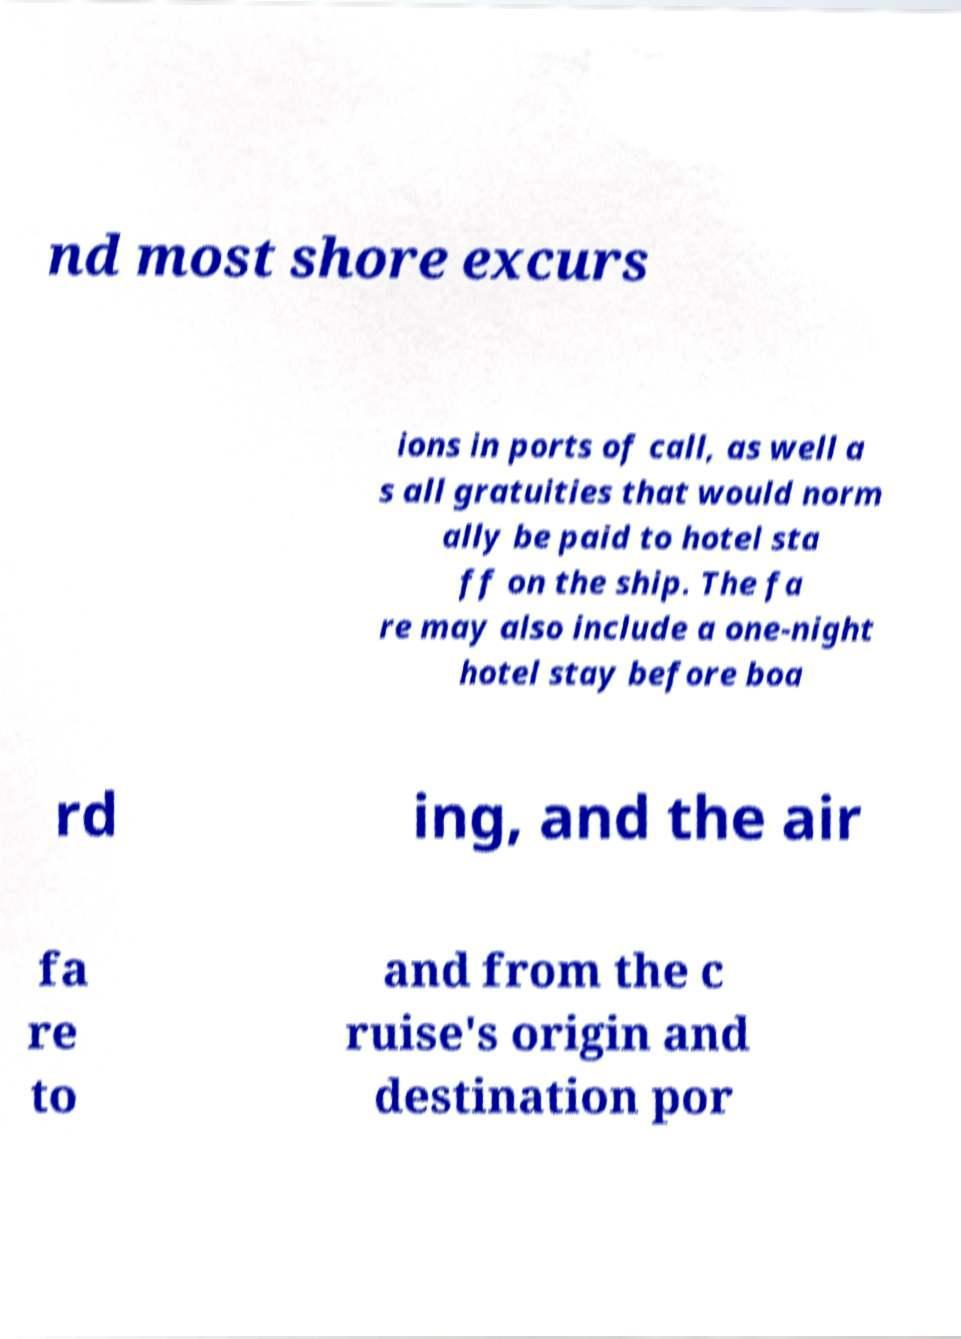I need the written content from this picture converted into text. Can you do that? nd most shore excurs ions in ports of call, as well a s all gratuities that would norm ally be paid to hotel sta ff on the ship. The fa re may also include a one-night hotel stay before boa rd ing, and the air fa re to and from the c ruise's origin and destination por 